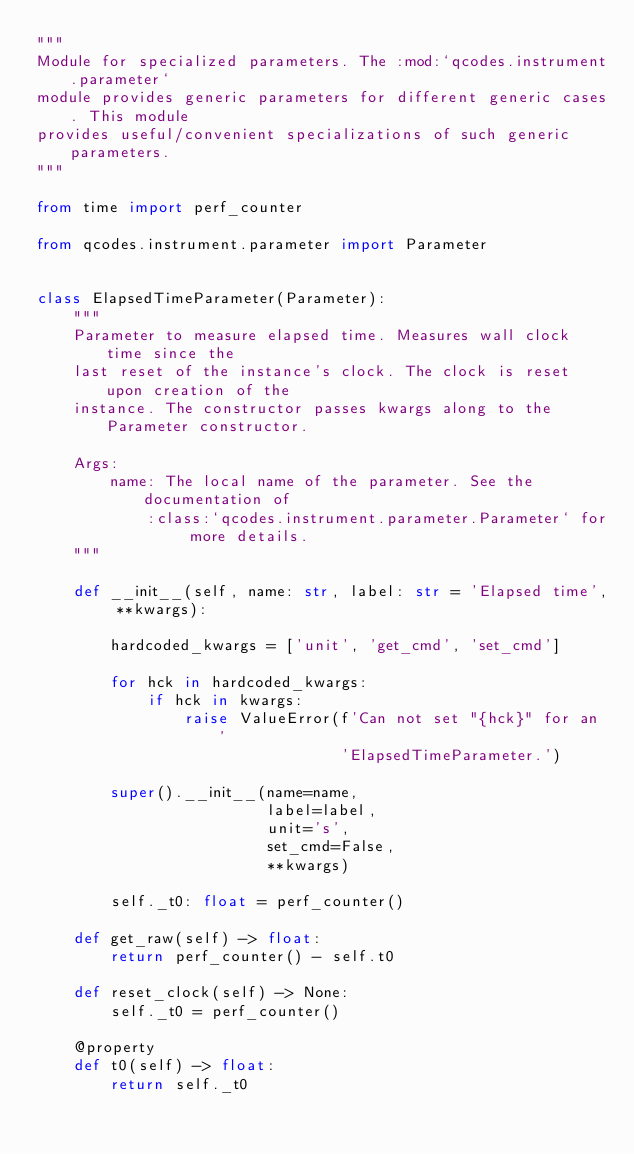<code> <loc_0><loc_0><loc_500><loc_500><_Python_>"""
Module for specialized parameters. The :mod:`qcodes.instrument.parameter`
module provides generic parameters for different generic cases. This module
provides useful/convenient specializations of such generic parameters.
"""

from time import perf_counter

from qcodes.instrument.parameter import Parameter


class ElapsedTimeParameter(Parameter):
    """
    Parameter to measure elapsed time. Measures wall clock time since the
    last reset of the instance's clock. The clock is reset upon creation of the
    instance. The constructor passes kwargs along to the Parameter constructor.

    Args:
        name: The local name of the parameter. See the documentation of
            :class:`qcodes.instrument.parameter.Parameter` for more details.
    """

    def __init__(self, name: str, label: str = 'Elapsed time', **kwargs):

        hardcoded_kwargs = ['unit', 'get_cmd', 'set_cmd']

        for hck in hardcoded_kwargs:
            if hck in kwargs:
                raise ValueError(f'Can not set "{hck}" for an '
                                 'ElapsedTimeParameter.')

        super().__init__(name=name,
                         label=label,
                         unit='s',
                         set_cmd=False,
                         **kwargs)

        self._t0: float = perf_counter()

    def get_raw(self) -> float:
        return perf_counter() - self.t0

    def reset_clock(self) -> None:
        self._t0 = perf_counter()

    @property
    def t0(self) -> float:
        return self._t0
</code> 